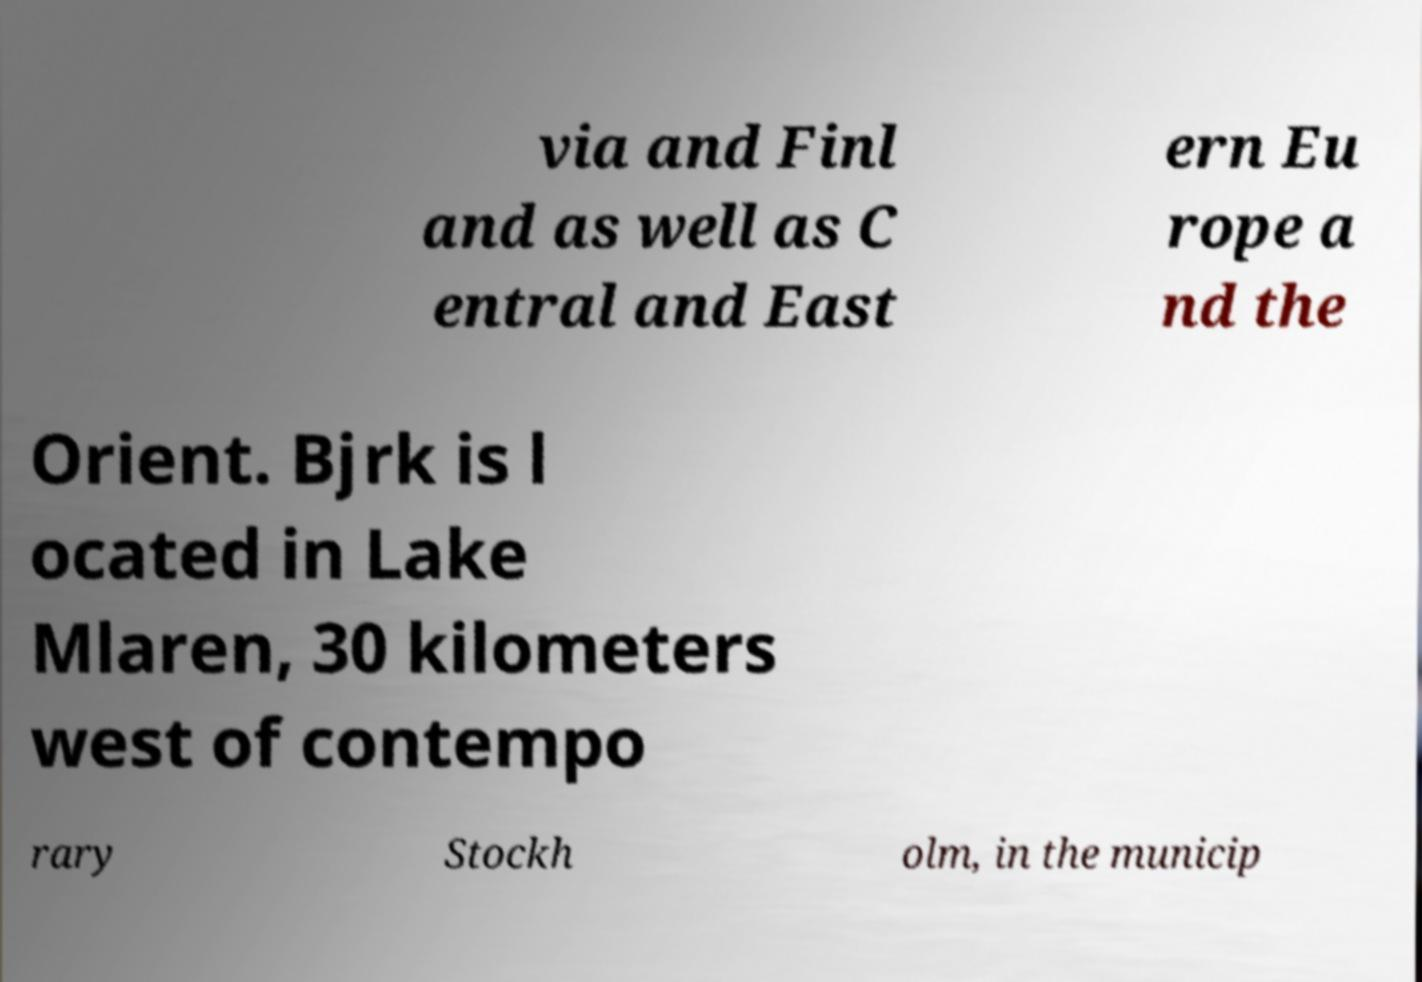There's text embedded in this image that I need extracted. Can you transcribe it verbatim? via and Finl and as well as C entral and East ern Eu rope a nd the Orient. Bjrk is l ocated in Lake Mlaren, 30 kilometers west of contempo rary Stockh olm, in the municip 